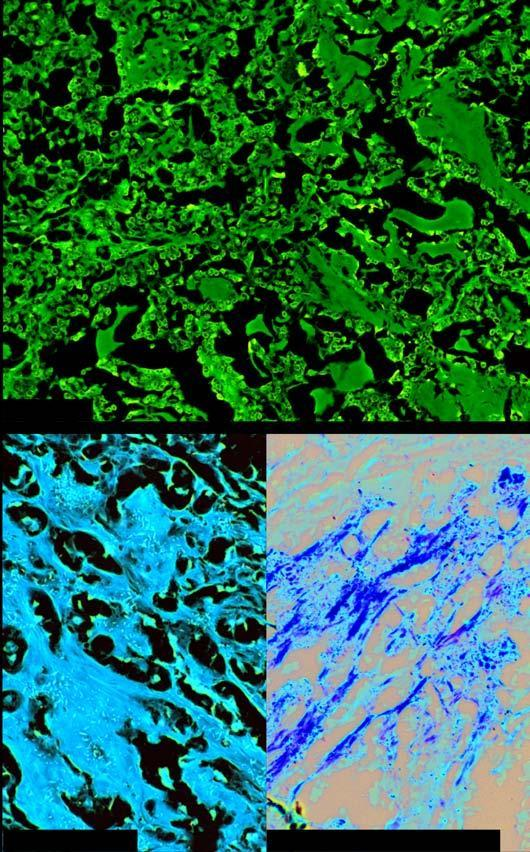does mononuclear inflammatory cell infiltrate show organoid pattern of oval tumour cells and abundant amyloid stroma?
Answer the question using a single word or phrase. No 